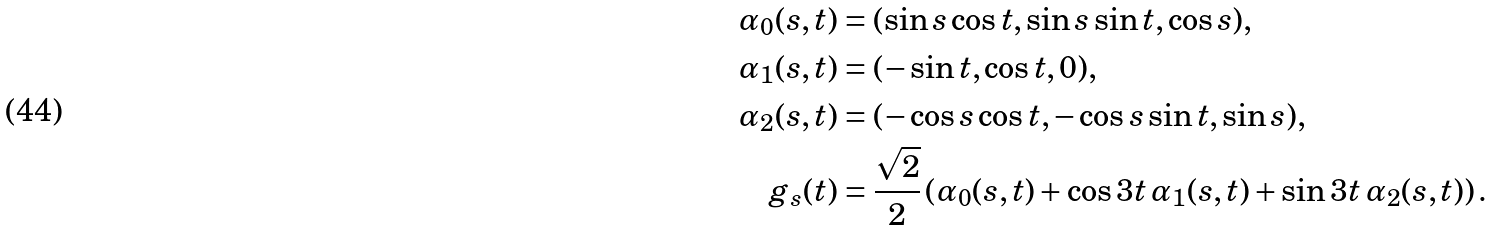Convert formula to latex. <formula><loc_0><loc_0><loc_500><loc_500>\alpha _ { 0 } ( s , t ) & = ( \sin s \cos t , \sin s \sin t , \cos s ) , \\ \alpha _ { 1 } ( s , t ) & = ( - \sin t , \cos t , 0 ) , \\ \alpha _ { 2 } ( s , t ) & = ( - \cos s \cos t , - \cos s \sin t , \sin s ) , \\ g _ { s } ( t ) & = \frac { \sqrt { 2 } } { 2 } \left ( \alpha _ { 0 } ( s , t ) + \cos 3 t \, \alpha _ { 1 } ( s , t ) + \sin 3 t \, \alpha _ { 2 } ( s , t ) \right ) .</formula> 